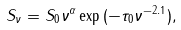<formula> <loc_0><loc_0><loc_500><loc_500>S _ { \nu } = S _ { 0 } \nu ^ { \alpha } \exp { ( - \tau _ { 0 } \nu ^ { - 2 . 1 } ) } ,</formula> 